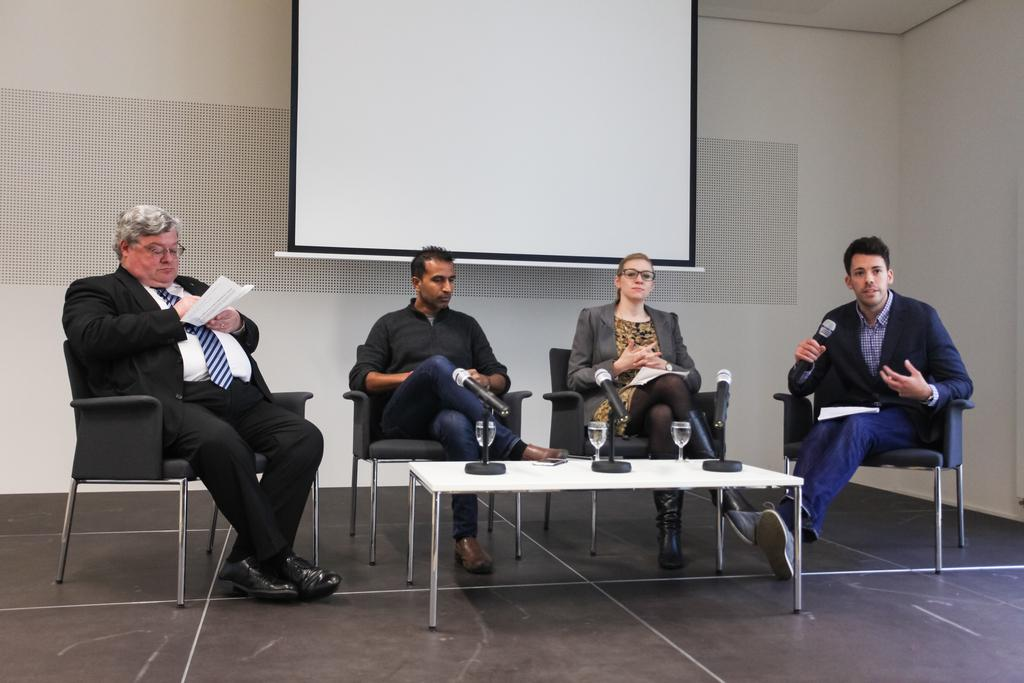How many people are in the room in the image? There are multiple persons in the room. What are the persons doing in the image? The persons are sitting on chairs. What objects are in front of the persons? There are microphones in front of the persons. Can you see any fangs on the persons in the image? There are no fangs visible on the persons in the image. How many fingers does each person have on their arm in the image? The image does not show the fingers or arms of the persons, so it cannot be determined from the image. 